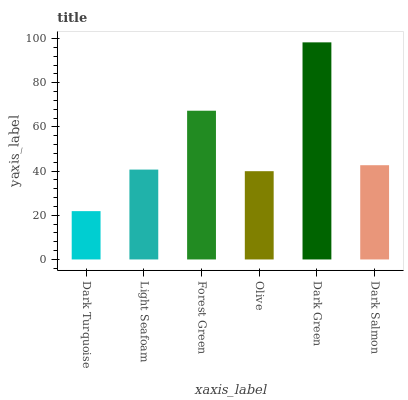Is Dark Turquoise the minimum?
Answer yes or no. Yes. Is Dark Green the maximum?
Answer yes or no. Yes. Is Light Seafoam the minimum?
Answer yes or no. No. Is Light Seafoam the maximum?
Answer yes or no. No. Is Light Seafoam greater than Dark Turquoise?
Answer yes or no. Yes. Is Dark Turquoise less than Light Seafoam?
Answer yes or no. Yes. Is Dark Turquoise greater than Light Seafoam?
Answer yes or no. No. Is Light Seafoam less than Dark Turquoise?
Answer yes or no. No. Is Dark Salmon the high median?
Answer yes or no. Yes. Is Light Seafoam the low median?
Answer yes or no. Yes. Is Light Seafoam the high median?
Answer yes or no. No. Is Olive the low median?
Answer yes or no. No. 